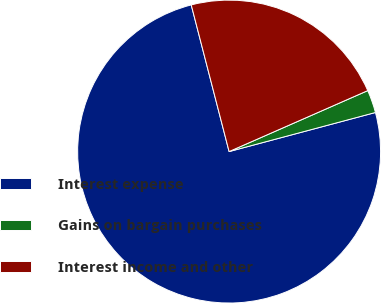Convert chart. <chart><loc_0><loc_0><loc_500><loc_500><pie_chart><fcel>Interest expense<fcel>Gains on bargain purchases<fcel>Interest income and other<nl><fcel>75.13%<fcel>2.44%<fcel>22.43%<nl></chart> 